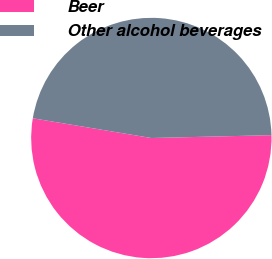Convert chart to OTSL. <chart><loc_0><loc_0><loc_500><loc_500><pie_chart><fcel>Beer<fcel>Other alcohol beverages<nl><fcel>53.0%<fcel>47.0%<nl></chart> 